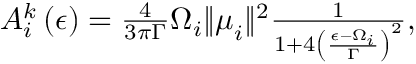<formula> <loc_0><loc_0><loc_500><loc_500>\begin{array} { r } { A _ { i } ^ { k } \left ( \epsilon \right ) = \frac { 4 } { 3 \pi \Gamma } \Omega _ { i } \| \mu _ { i } \| ^ { 2 } \frac { 1 } { 1 + 4 \left ( \frac { \epsilon - \Omega _ { i } } { \Gamma } \right ) ^ { 2 } } , } \end{array}</formula> 